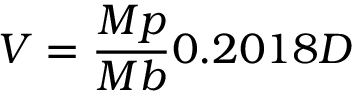Convert formula to latex. <formula><loc_0><loc_0><loc_500><loc_500>V = { \frac { M p } { M b } } 0 . 2 0 1 8 D</formula> 